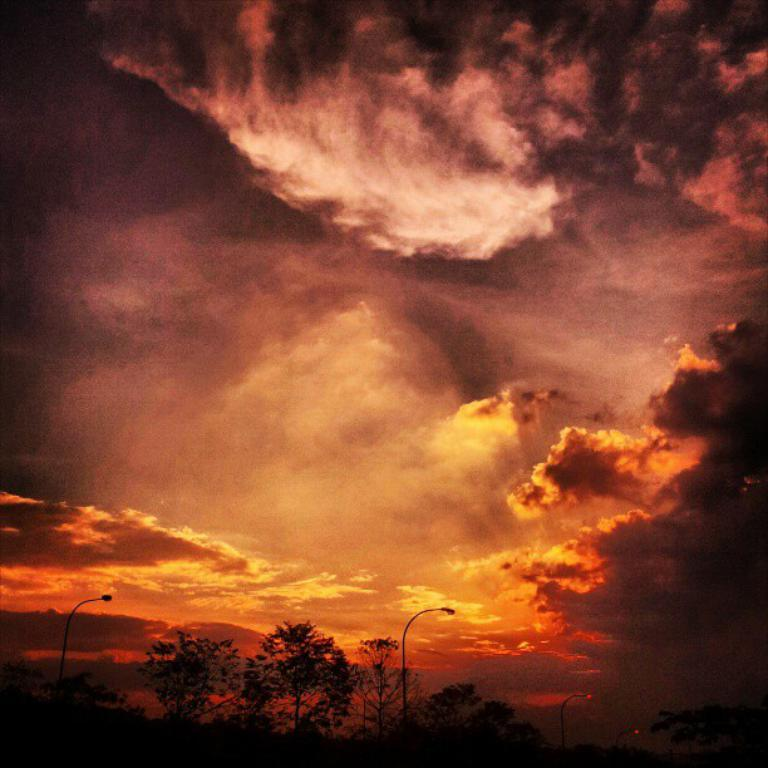What type of vegetation is present at the bottom of the picture? There are trees at the bottom of the picture. What else can be found at the bottom of the picture? There are street lights at the bottom of the picture. What can be seen in the background of the image? Clouds are visible in the background. What colors are present in the sky? The sky is blue and orange in color. How much does the twig cost in the image? There is no twig present in the image, so it cannot be assigned a price. 